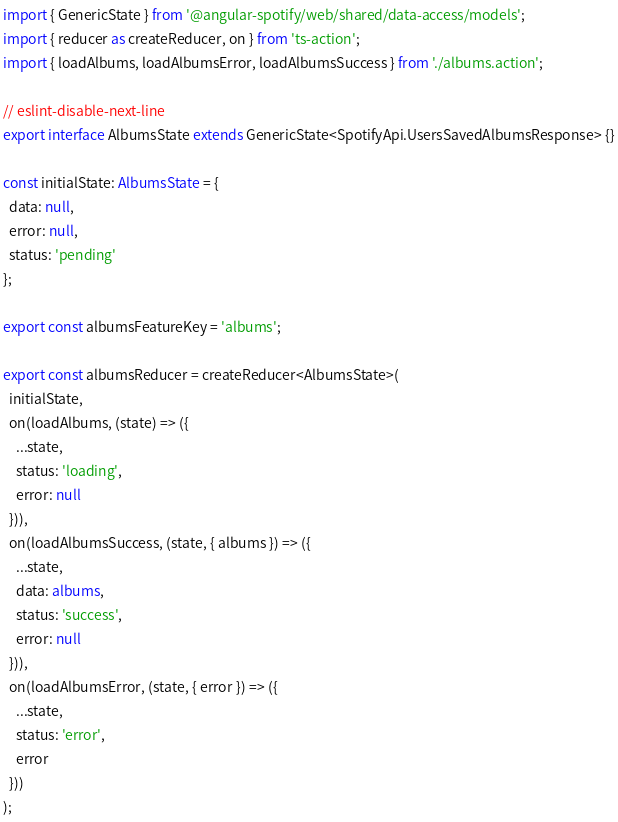<code> <loc_0><loc_0><loc_500><loc_500><_TypeScript_>import { GenericState } from '@angular-spotify/web/shared/data-access/models';
import { reducer as createReducer, on } from 'ts-action';
import { loadAlbums, loadAlbumsError, loadAlbumsSuccess } from './albums.action';

// eslint-disable-next-line
export interface AlbumsState extends GenericState<SpotifyApi.UsersSavedAlbumsResponse> {}

const initialState: AlbumsState = {
  data: null,
  error: null,
  status: 'pending'
};

export const albumsFeatureKey = 'albums';

export const albumsReducer = createReducer<AlbumsState>(
  initialState,
  on(loadAlbums, (state) => ({
    ...state,
    status: 'loading',
    error: null
  })),
  on(loadAlbumsSuccess, (state, { albums }) => ({
    ...state,
    data: albums,
    status: 'success',
    error: null
  })),
  on(loadAlbumsError, (state, { error }) => ({
    ...state,
    status: 'error',
    error
  }))
);
</code> 